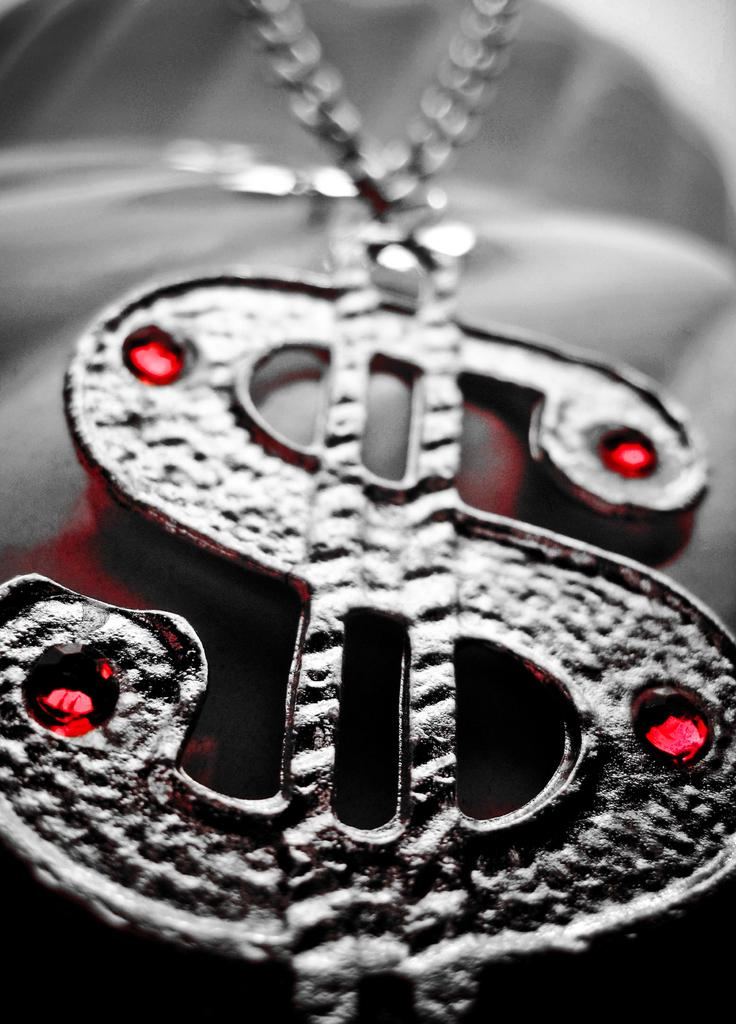What is the main object in the image? There is a dollar symbol locket in the image. Where is the locket located? The locket is present over a place. How much dust is present on the locket in the image? The provided facts do not mention any dust on the locket, so it cannot be determined from the image. Who is the owner of the locket in the image? The provided facts do not mention the owner of the locket, so it cannot be determined from the image. 